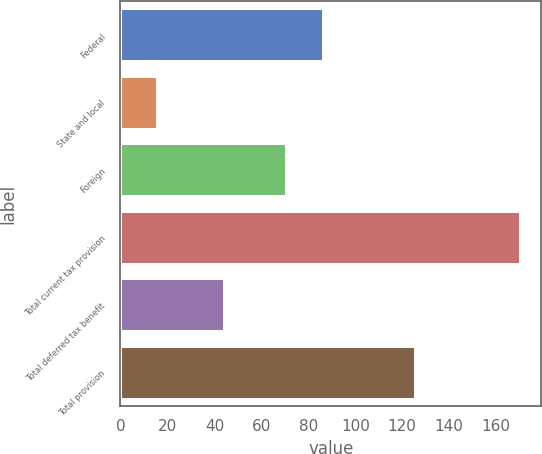Convert chart to OTSL. <chart><loc_0><loc_0><loc_500><loc_500><bar_chart><fcel>Federal<fcel>State and local<fcel>Foreign<fcel>Total current tax provision<fcel>Total deferred tax benefit<fcel>Total provision<nl><fcel>86.47<fcel>16<fcel>71<fcel>170.7<fcel>44.7<fcel>126<nl></chart> 